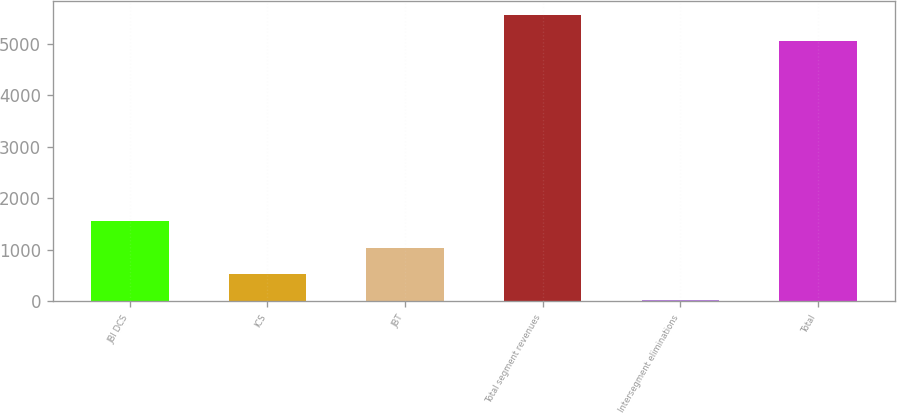Convert chart. <chart><loc_0><loc_0><loc_500><loc_500><bar_chart><fcel>JBI DCS<fcel>ICS<fcel>JBT<fcel>Total segment revenues<fcel>Intersegment eliminations<fcel>Total<nl><fcel>1552.5<fcel>541.5<fcel>1047<fcel>5560.5<fcel>36<fcel>5055<nl></chart> 